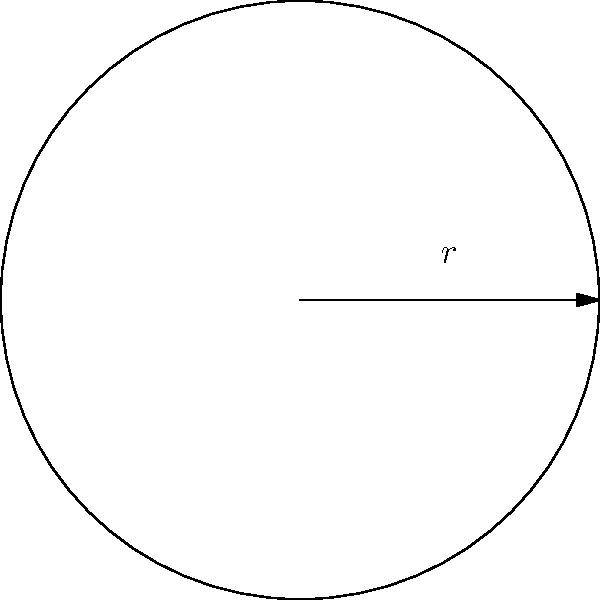Marie Müller, the star player of the German national football team, has been awarded a spherical trophy for her outstanding performance in the World Cup. The radius of the trophy is 10 cm. What is the volume of this trophy in cubic centimeters? To find the volume of a spherical trophy, we need to use the formula for the volume of a sphere:

$$V = \frac{4}{3}\pi r^3$$

Where:
$V$ = volume of the sphere
$r$ = radius of the sphere
$\pi$ ≈ 3.14159 (we'll use this approximation)

Given:
Radius (r) = 10 cm

Let's substitute these values into the formula:

$$V = \frac{4}{3} \times \pi \times 10^3$$

$$V = \frac{4}{3} \times 3.14159 \times 1000$$

$$V ≈ 4188.79 \text{ cm}^3$$

Rounding to the nearest whole number:

$$V ≈ 4189 \text{ cm}^3$$

Therefore, the volume of Marie Müller's spherical trophy is approximately 4189 cubic centimeters.
Answer: 4189 cm³ 